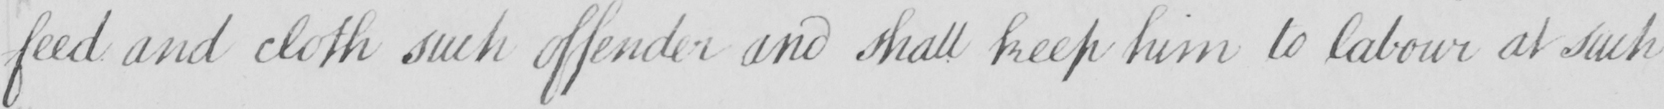What does this handwritten line say? feed and cloth such offender and shall keep him to labour at such 